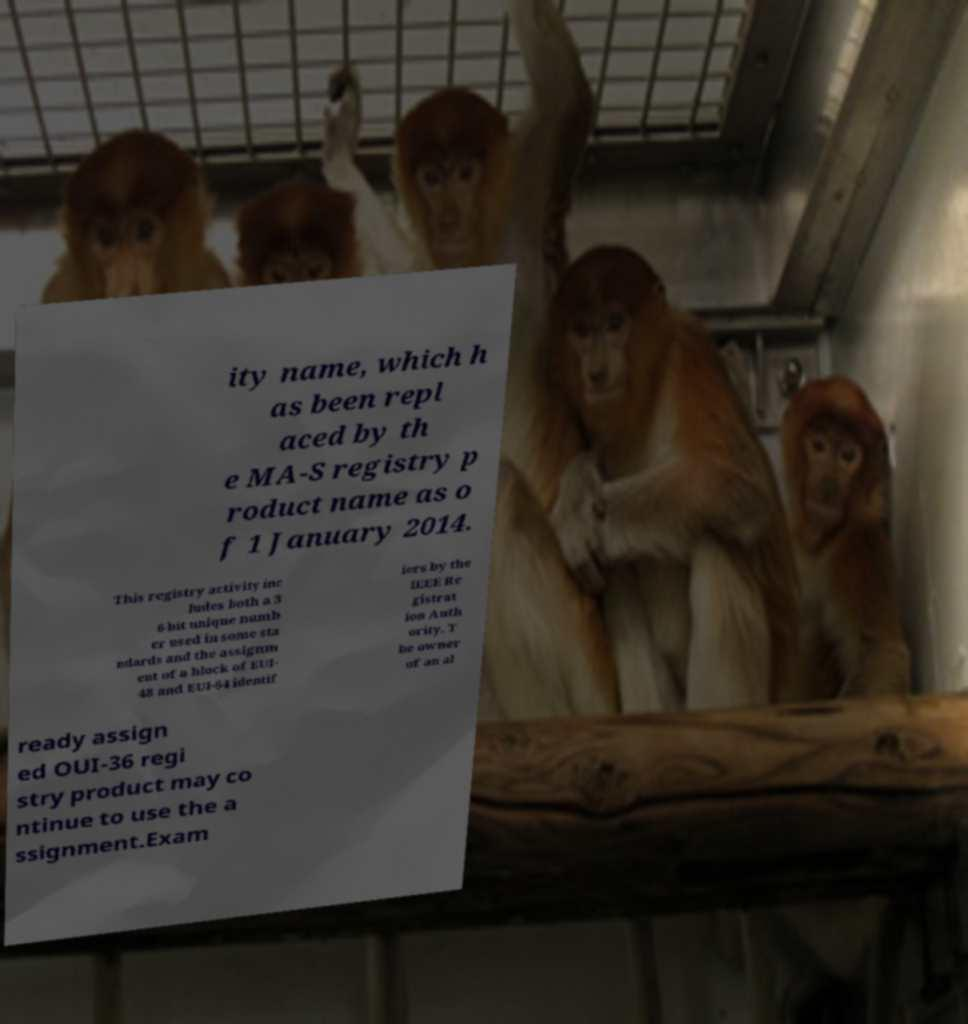There's text embedded in this image that I need extracted. Can you transcribe it verbatim? ity name, which h as been repl aced by th e MA-S registry p roduct name as o f 1 January 2014. This registry activity inc ludes both a 3 6-bit unique numb er used in some sta ndards and the assignm ent of a block of EUI- 48 and EUI-64 identif iers by the IEEE Re gistrat ion Auth ority. T he owner of an al ready assign ed OUI-36 regi stry product may co ntinue to use the a ssignment.Exam 